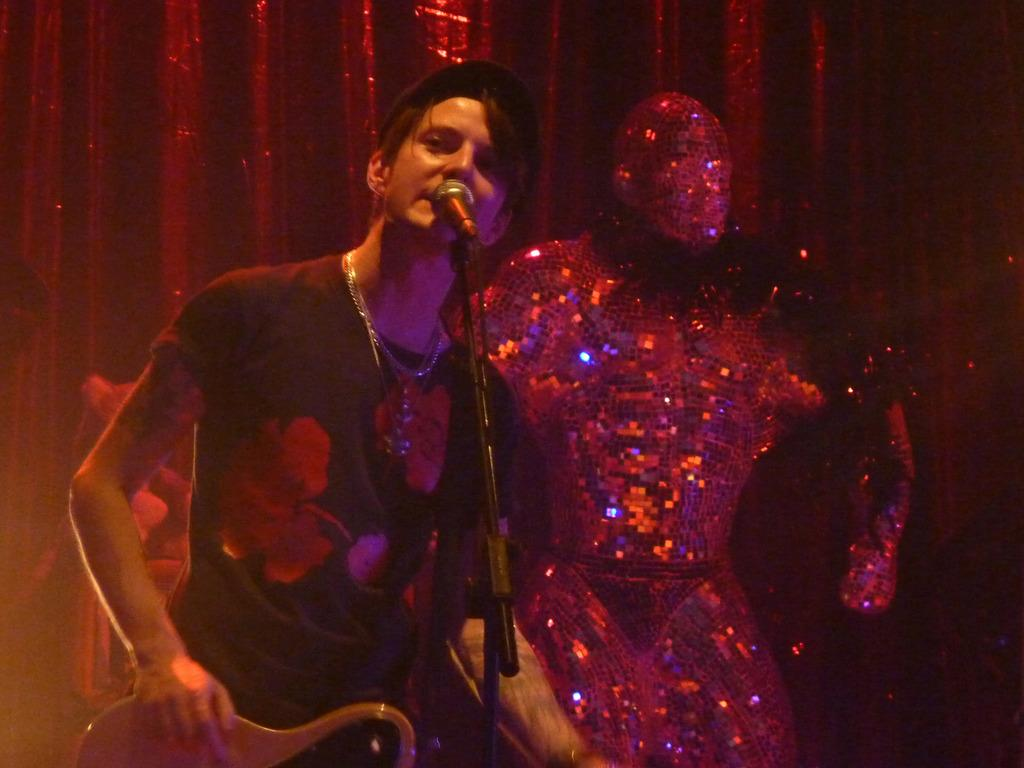What is the main object in the middle of the image? There is a microphone in the middle of the image. Who is standing near the microphone? A person is standing behind the microphone. What instrument is the person holding? The person is holding a guitar. What additional object can be seen in the image? There is a statue visible in the image. What type of material is present in the image? There is cloth present in the image. What type of animals can be seen at the zoo in the image? There is no zoo or animals present in the image. What day of the week is it in the image? The day of the week cannot be determined from the image. 